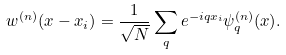Convert formula to latex. <formula><loc_0><loc_0><loc_500><loc_500>w ^ { ( n ) } ( x - x _ { i } ) = \frac { 1 } { \sqrt { N } } \sum _ { q } e ^ { - i q x _ { i } } \psi _ { q } ^ { ( n ) } ( x ) .</formula> 